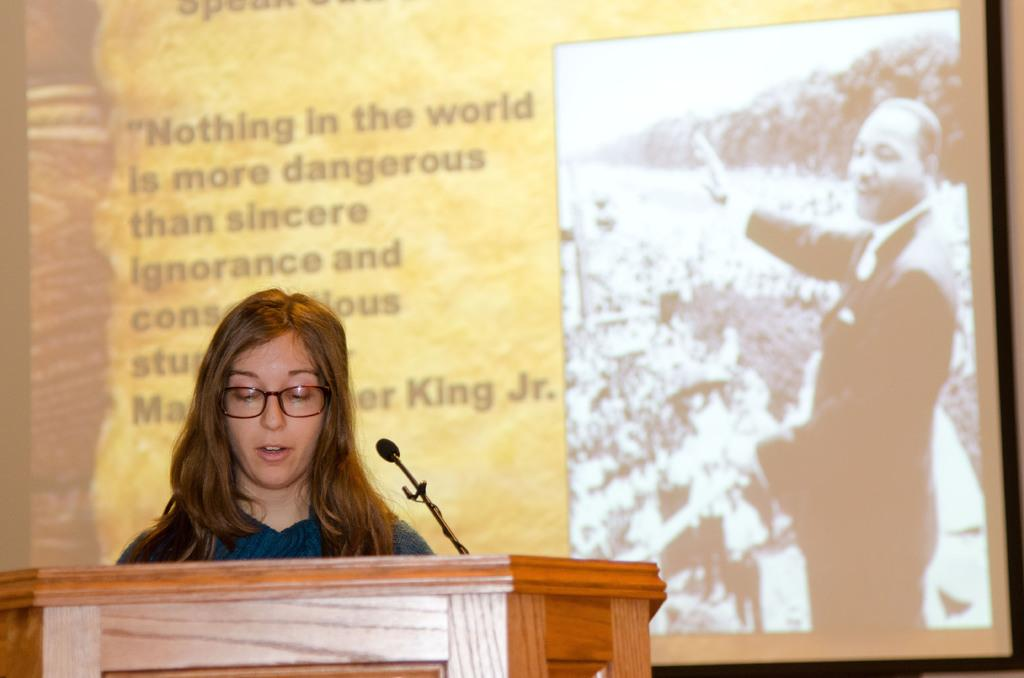What is the person near in the image? The person is standing near a podium. What is on the podium? There is a mic on the podium. What can be seen in the background of the image? There is a presentation screen in the background. What is displayed on the presentation screen? The presentation screen contains text and an image. What type of pickle is being used as a prop on the podium? There is no pickle present in the image; it is a mic on the podium. Can you describe the sleet falling outside the room in the image? There is no mention of sleet or any outdoor elements in the image; it is an indoor setting with a podium, mic, presentation screen, and a person standing nearby. 